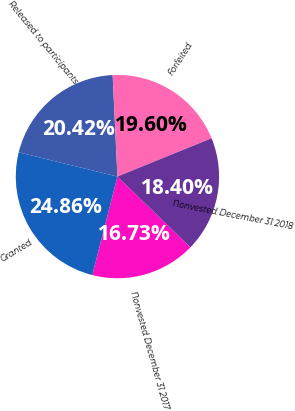<chart> <loc_0><loc_0><loc_500><loc_500><pie_chart><fcel>Nonvested December 31 2017<fcel>Granted<fcel>Released to participants<fcel>Forfeited<fcel>Nonvested December 31 2018<nl><fcel>16.73%<fcel>24.86%<fcel>20.42%<fcel>19.6%<fcel>18.4%<nl></chart> 